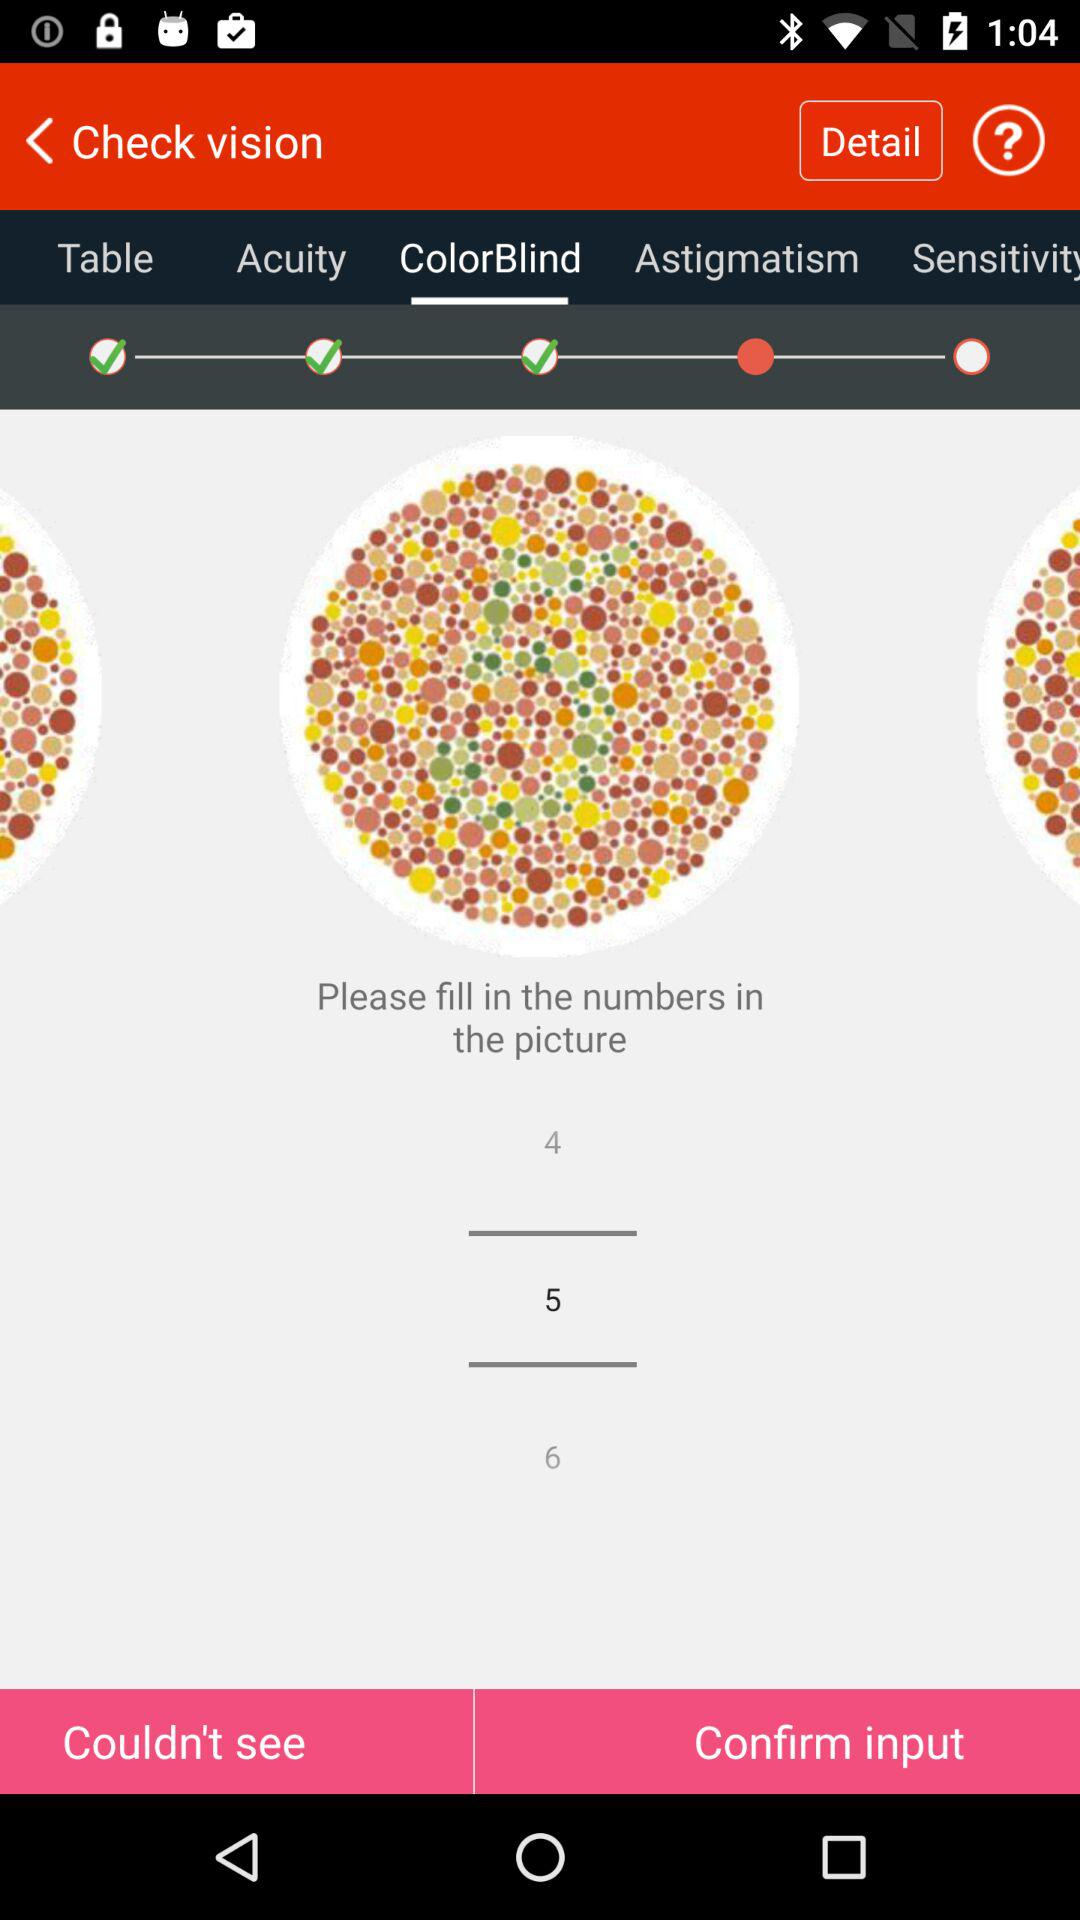Which tab is selected? The tab "ColorBlind" is selected. 